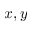<formula> <loc_0><loc_0><loc_500><loc_500>x , y</formula> 